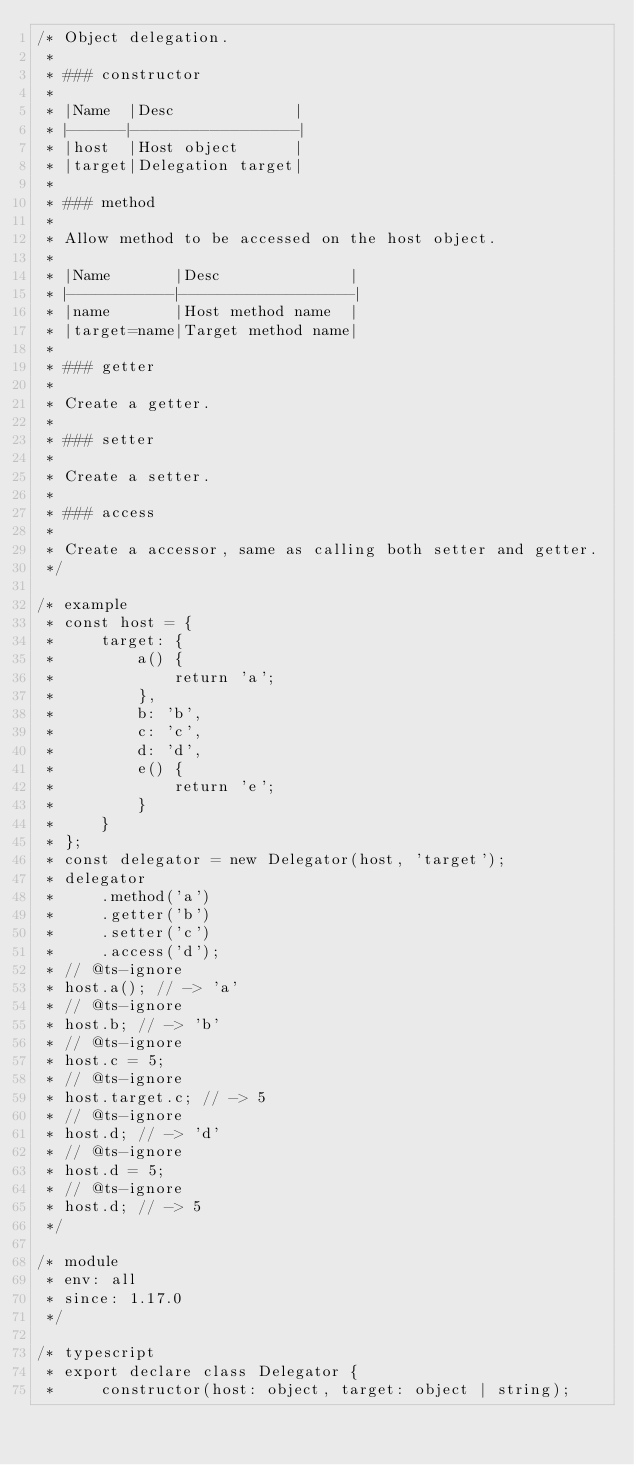Convert code to text. <code><loc_0><loc_0><loc_500><loc_500><_JavaScript_>/* Object delegation.
 *
 * ### constructor
 *
 * |Name  |Desc             |
 * |------|-----------------|
 * |host  |Host object      |
 * |target|Delegation target|
 *
 * ### method
 *
 * Allow method to be accessed on the host object.
 *
 * |Name       |Desc              |
 * |-----------|------------------|
 * |name       |Host method name  |
 * |target=name|Target method name|
 *
 * ### getter
 *
 * Create a getter.
 *
 * ### setter
 *
 * Create a setter.
 *
 * ### access
 *
 * Create a accessor, same as calling both setter and getter.
 */

/* example
 * const host = {
 *     target: {
 *         a() {
 *             return 'a';
 *         },
 *         b: 'b',
 *         c: 'c',
 *         d: 'd',
 *         e() {
 *             return 'e';
 *         }
 *     }
 * };
 * const delegator = new Delegator(host, 'target');
 * delegator
 *     .method('a')
 *     .getter('b')
 *     .setter('c')
 *     .access('d');
 * // @ts-ignore
 * host.a(); // -> 'a'
 * // @ts-ignore
 * host.b; // -> 'b'
 * // @ts-ignore
 * host.c = 5;
 * // @ts-ignore
 * host.target.c; // -> 5
 * // @ts-ignore
 * host.d; // -> 'd'
 * // @ts-ignore
 * host.d = 5;
 * // @ts-ignore
 * host.d; // -> 5
 */

/* module
 * env: all
 * since: 1.17.0
 */

/* typescript
 * export declare class Delegator {
 *     constructor(host: object, target: object | string);</code> 